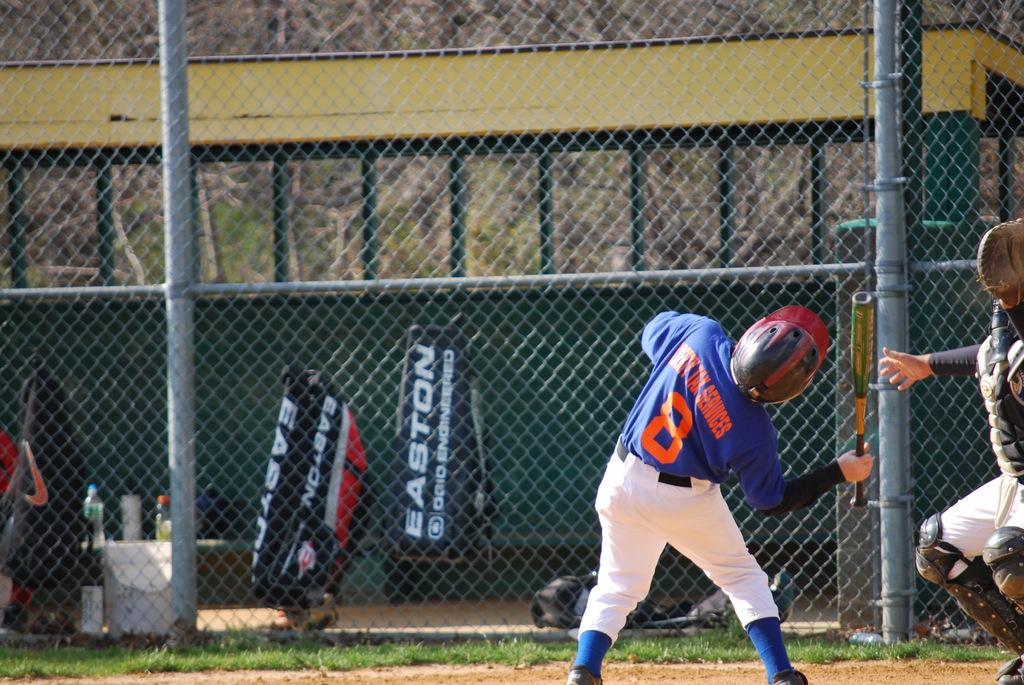<image>
Write a terse but informative summary of the picture. Number 8 sponsored by Liberty Tax Services plays baseball. 